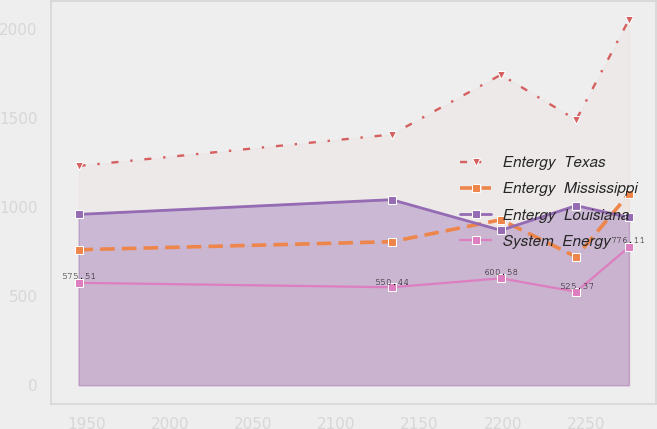<chart> <loc_0><loc_0><loc_500><loc_500><line_chart><ecel><fcel>Entergy  Texas<fcel>Entergy  Mississippi<fcel>Entergy  Louisiana<fcel>System  Energy<nl><fcel>1945.24<fcel>1231.89<fcel>761.06<fcel>959.74<fcel>575.51<nl><fcel>2133.22<fcel>1408.34<fcel>806.3<fcel>1042.48<fcel>550.44<nl><fcel>2198.79<fcel>1744.05<fcel>929.82<fcel>870.42<fcel>600.58<nl><fcel>2243.97<fcel>1490.51<fcel>721.15<fcel>1008.99<fcel>525.37<nl><fcel>2275.67<fcel>2053.63<fcel>1075.16<fcel>942.53<fcel>776.11<nl></chart> 